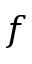Convert formula to latex. <formula><loc_0><loc_0><loc_500><loc_500>f</formula> 